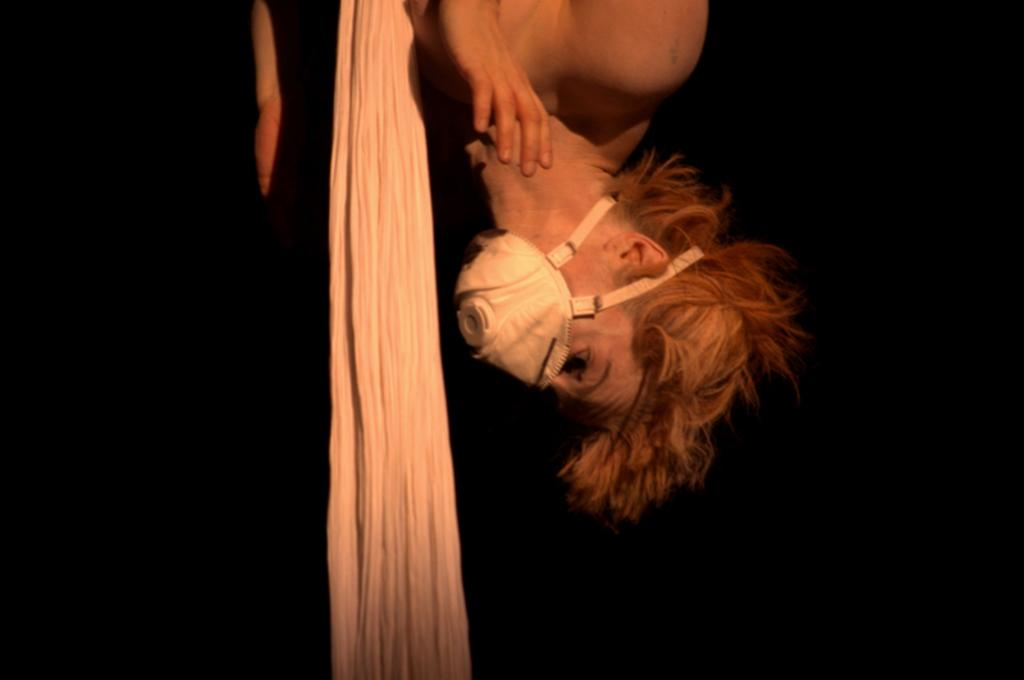Who is present in the image? There is a woman in the image. What is the woman wearing on her face? The woman is wearing a mask. What object is located near the woman? There is a cloth beside the woman. How would you describe the overall appearance of the image? The backdrop of the image is dark. What type of stew is being prepared in the image? There is no stew present in the image. What question is the woman asking in the image? The image does not show the woman asking a question. 